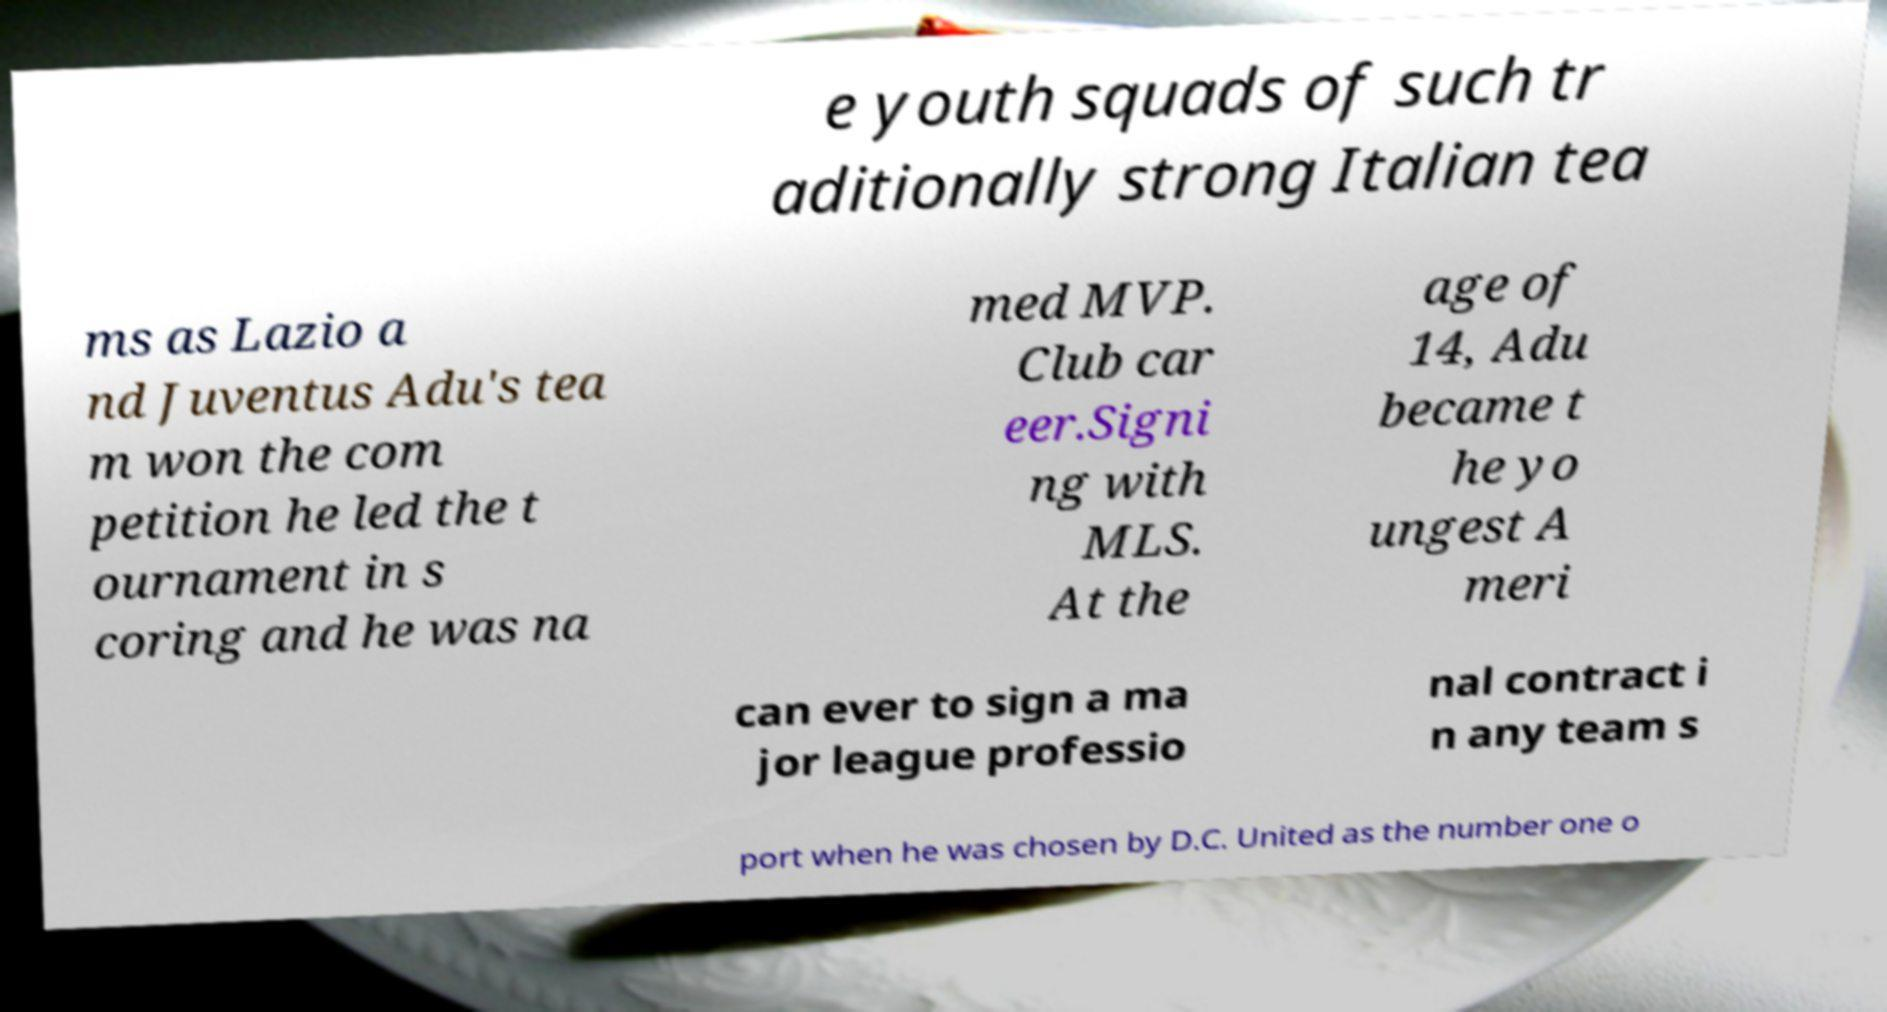Can you accurately transcribe the text from the provided image for me? e youth squads of such tr aditionally strong Italian tea ms as Lazio a nd Juventus Adu's tea m won the com petition he led the t ournament in s coring and he was na med MVP. Club car eer.Signi ng with MLS. At the age of 14, Adu became t he yo ungest A meri can ever to sign a ma jor league professio nal contract i n any team s port when he was chosen by D.C. United as the number one o 